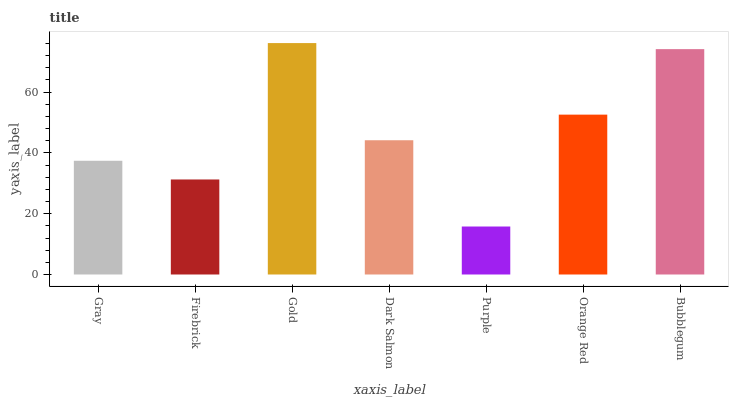Is Purple the minimum?
Answer yes or no. Yes. Is Gold the maximum?
Answer yes or no. Yes. Is Firebrick the minimum?
Answer yes or no. No. Is Firebrick the maximum?
Answer yes or no. No. Is Gray greater than Firebrick?
Answer yes or no. Yes. Is Firebrick less than Gray?
Answer yes or no. Yes. Is Firebrick greater than Gray?
Answer yes or no. No. Is Gray less than Firebrick?
Answer yes or no. No. Is Dark Salmon the high median?
Answer yes or no. Yes. Is Dark Salmon the low median?
Answer yes or no. Yes. Is Gray the high median?
Answer yes or no. No. Is Bubblegum the low median?
Answer yes or no. No. 